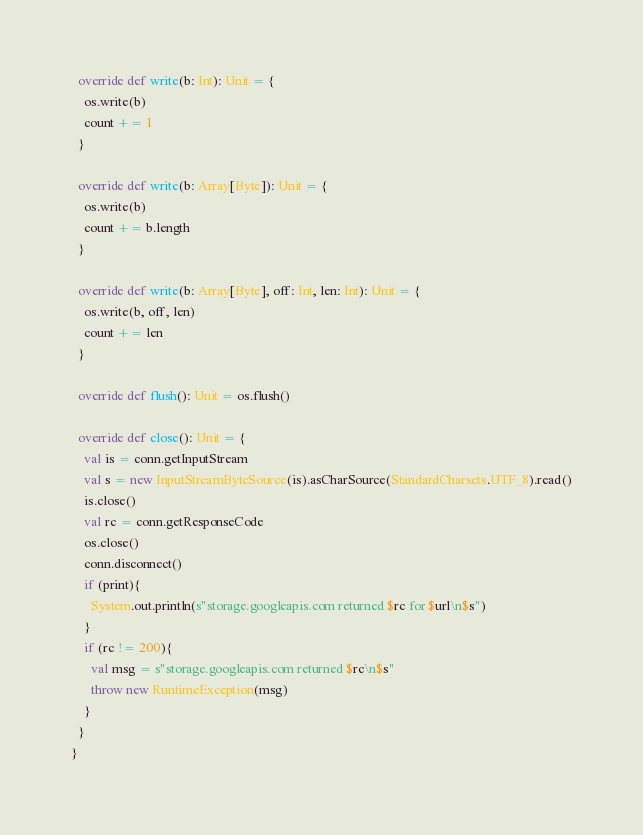<code> <loc_0><loc_0><loc_500><loc_500><_Scala_>
  override def write(b: Int): Unit = {
    os.write(b)
    count += 1
  }

  override def write(b: Array[Byte]): Unit = {
    os.write(b)
    count += b.length
  }

  override def write(b: Array[Byte], off: Int, len: Int): Unit = {
    os.write(b, off, len)
    count += len
  }

  override def flush(): Unit = os.flush()

  override def close(): Unit = {
    val is = conn.getInputStream
    val s = new InputStreamByteSource(is).asCharSource(StandardCharsets.UTF_8).read()
    is.close()
    val rc = conn.getResponseCode
    os.close()
    conn.disconnect()
    if (print){
      System.out.println(s"storage.googleapis.com returned $rc for $url\n$s")
    }
    if (rc != 200){
      val msg = s"storage.googleapis.com returned $rc\n$s"
      throw new RuntimeException(msg)
    }
  }
}
</code> 